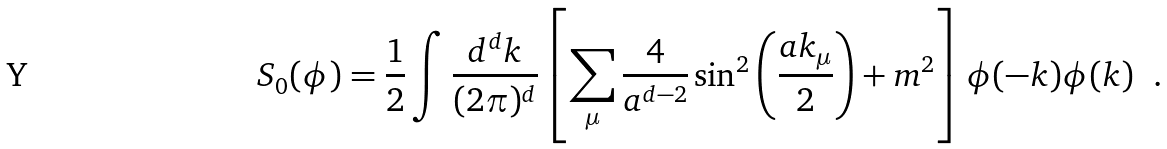Convert formula to latex. <formula><loc_0><loc_0><loc_500><loc_500>S _ { 0 } ( \phi ) = \frac { 1 } { 2 } \int \frac { d ^ { d } k } { ( 2 \pi ) ^ { d } } \left [ \sum _ { \mu } \frac { 4 } { a ^ { d - 2 } } \sin ^ { 2 } \left ( \frac { a k _ { \mu } } { 2 } \right ) + m ^ { 2 } \right ] \phi ( - k ) \phi ( k ) \ \ .</formula> 